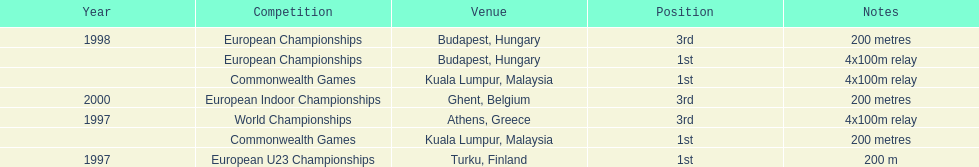How many times was golding in 2nd position? 0. 